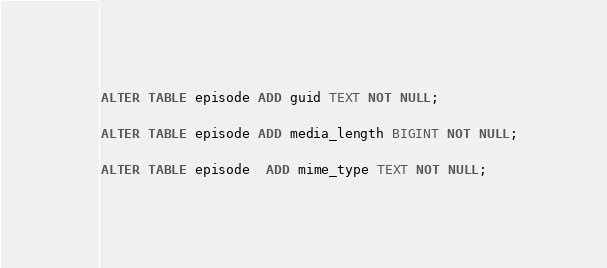<code> <loc_0><loc_0><loc_500><loc_500><_SQL_>ALTER TABLE episode ADD guid TEXT NOT NULL;

ALTER TABLE episode ADD media_length BIGINT NOT NULL;

ALTER TABLE episode  ADD mime_type TEXT NOT NULL;

</code> 